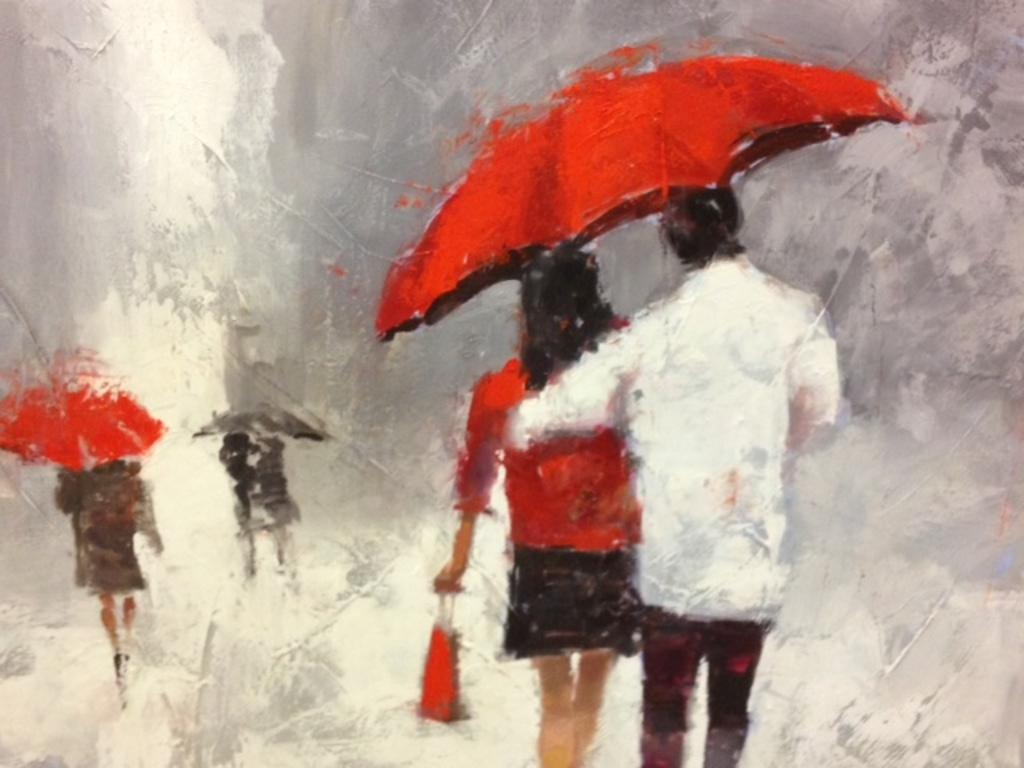How many people are in the image? There are persons in the image. What are the persons holding in the image? The persons are holding umbrellas. What are the persons doing in the image? The persons are walking on a road. What type of unit is visible in the image? There is no unit present in the image; it features persons holding umbrellas and walking on a road. What type of army is depicted in the image? There is no army present in the image; it features persons holding umbrellas and walking on a road. 